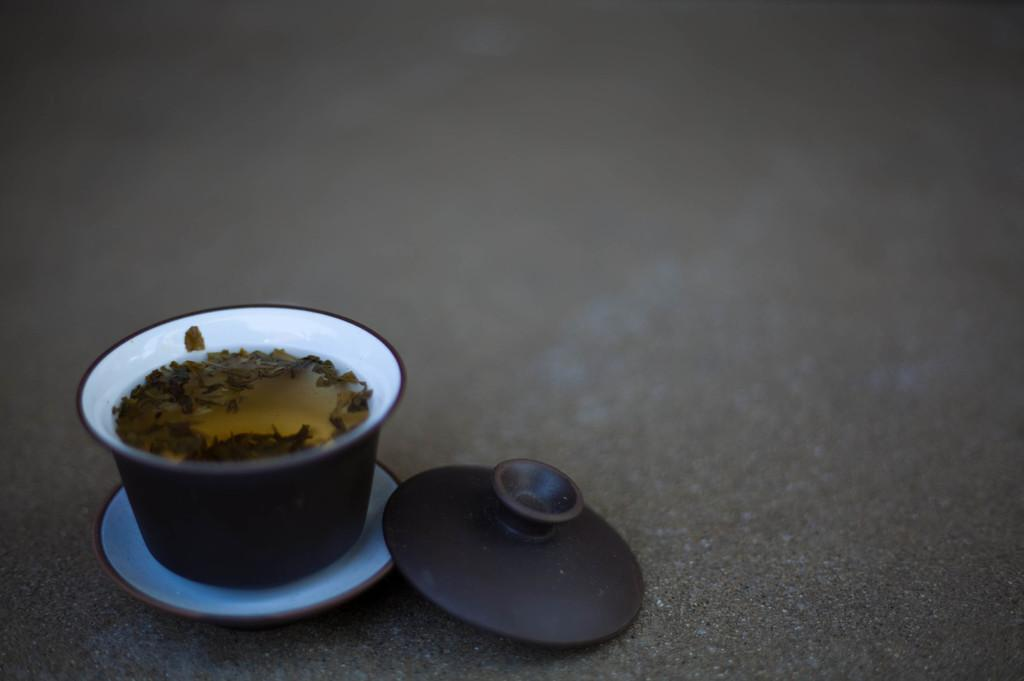What is in the mug that is visible in the image? There is a beverage in a mug in the image. What type of approval does the doll receive from the beverage in the image? There is no doll present in the image, so it is not possible to determine any approval from the beverage. 